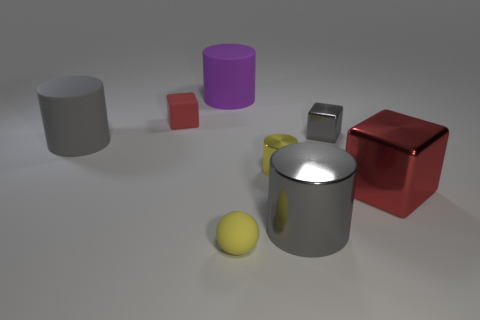Subtract 1 cylinders. How many cylinders are left? 3 Add 1 small green blocks. How many objects exist? 9 Subtract all balls. How many objects are left? 7 Subtract 2 gray cylinders. How many objects are left? 6 Subtract all large red blocks. Subtract all big gray matte cylinders. How many objects are left? 6 Add 2 purple things. How many purple things are left? 3 Add 2 big brown metallic blocks. How many big brown metallic blocks exist? 2 